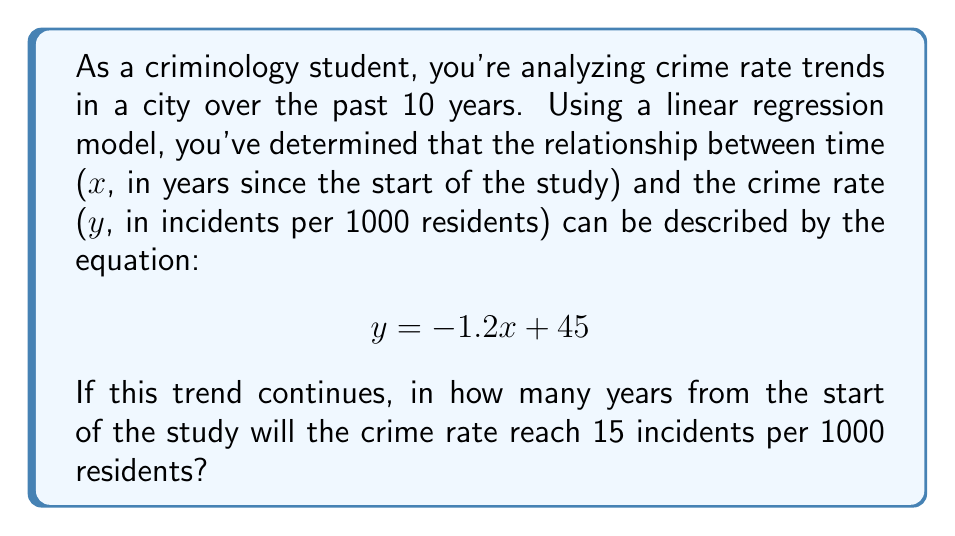Can you answer this question? To solve this problem, we'll follow these steps:

1) We have the linear equation: $y = -1.2x + 45$

2) We want to find x when y = 15 (the target crime rate)

3) Substitute y = 15 into the equation:
   $15 = -1.2x + 45$

4) Subtract 45 from both sides:
   $15 - 45 = -1.2x + 45 - 45$
   $-30 = -1.2x$

5) Divide both sides by -1.2:
   $\frac{-30}{-1.2} = \frac{-1.2x}{-1.2}$
   $25 = x$

Therefore, it will take 25 years from the start of the study for the crime rate to reach 15 incidents per 1000 residents if the trend continues.
Answer: 25 years 